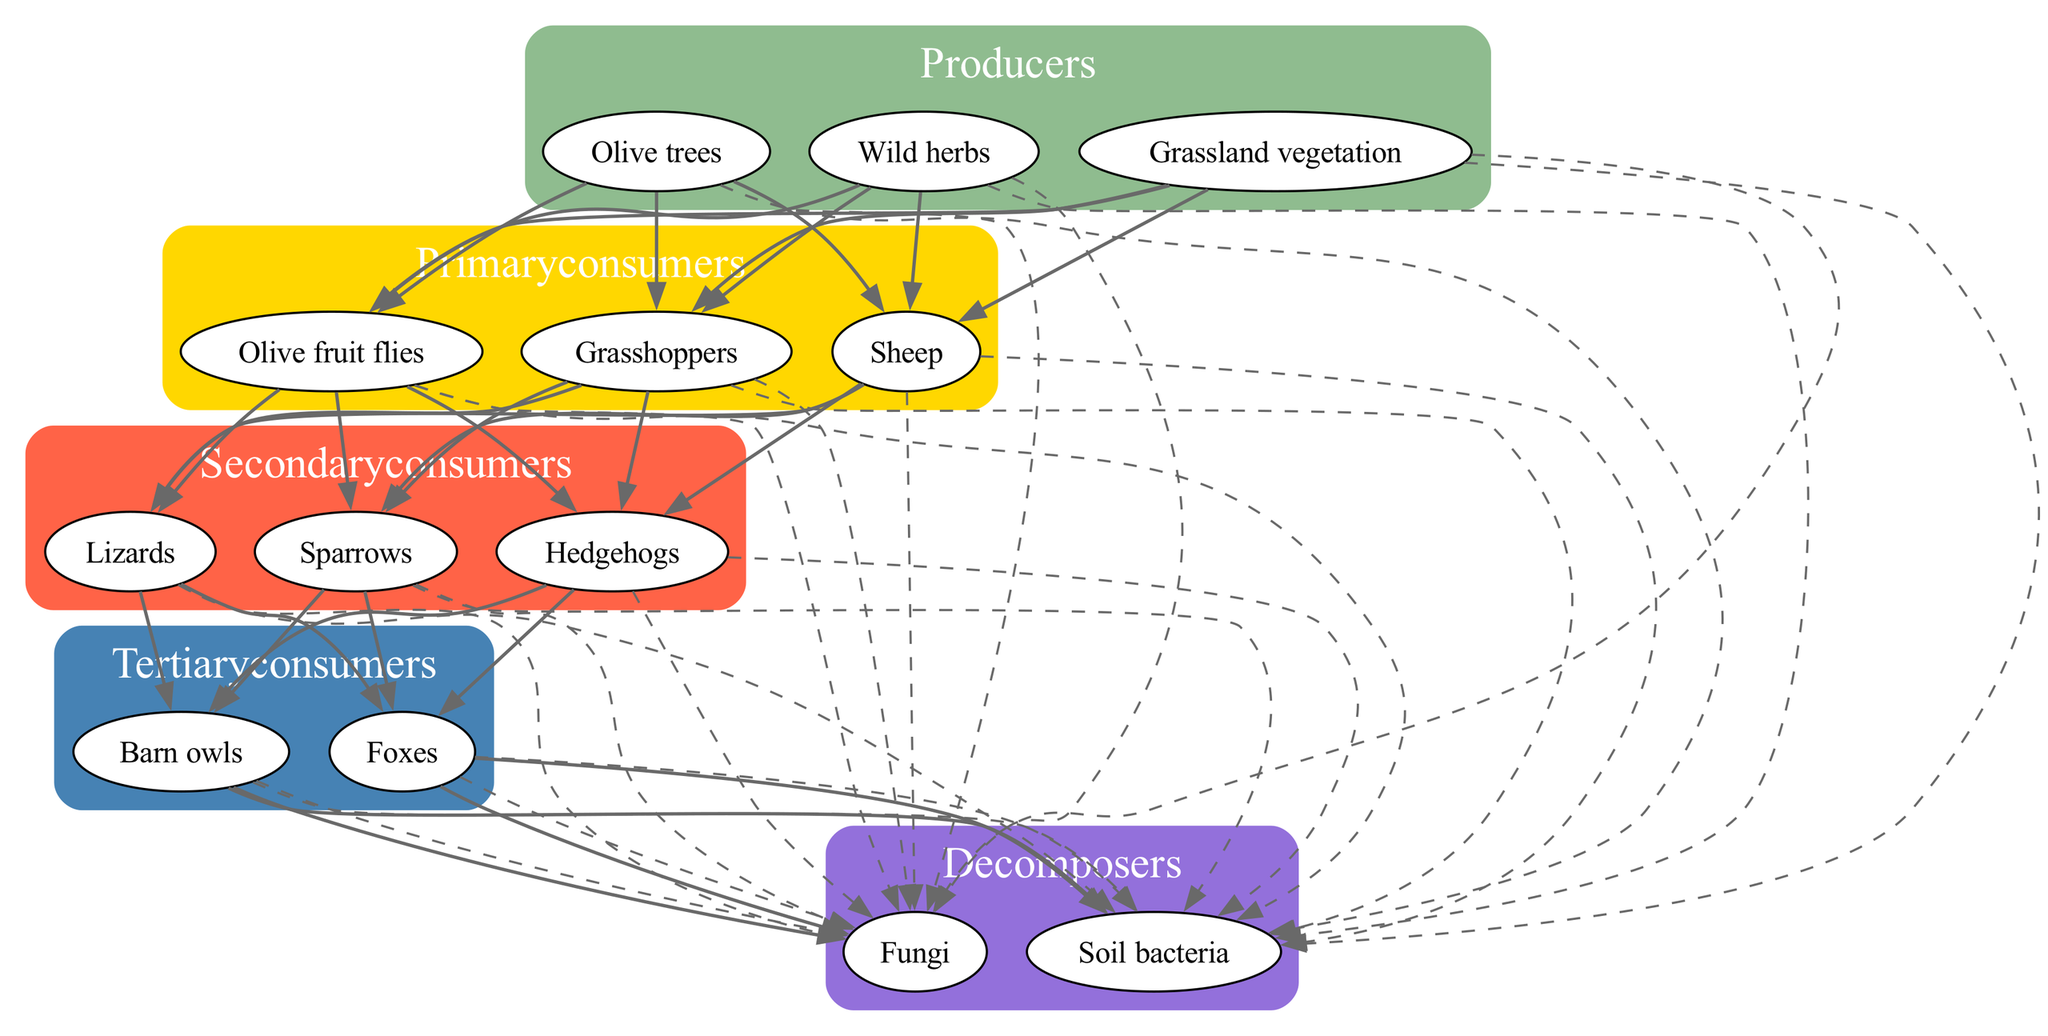What are the producers in this food chain? The diagram lists three organisms as producers: olive trees, wild herbs, and grassland vegetation. These are the starting point of the food chain.
Answer: Olive trees, wild herbs, grassland vegetation How many primary consumers are present? The diagram indicates there are three primary consumers: olive fruit flies, grasshoppers, and sheep. This is counted directly from the primary consumer section of the diagram.
Answer: 3 Which organisms directly feed on olive trees? Olive fruit flies are identified as primary consumers that feed directly on olive trees. They represent an interaction between producers and primary consumers.
Answer: Olive fruit flies What is the role of decomposers in the food chain? Decomposers like fungi and soil bacteria recycle nutrients back into the ecosystem by breaking down dead plants and animals. They are crucial for nutrient cycling in the food chain.
Answer: Nutrient recycling How many total organisms are in the secondary consumer category? According to the diagram, there are three organisms in the secondary consumer category: lizards, sparrows, and hedgehogs, giving us a total count.
Answer: 3 Which tertiary consumer preys on lizards? Barn owls are identified as tertiary consumers in this food chain, and they prey on lizards found in the secondary consumer category. This reflects the predatory relationship.
Answer: Barn owls What role do soil bacteria play in the ecosystem? Soil bacteria act as decomposers, breaking down organic matter, which helps to recycle nutrients back into the soil, supporting plant growth and ecosystem sustainability.
Answer: Decomposer How many edges lead from primary consumers to secondary consumers? There are three primary consumers and three secondary consumers. Each primary consumer can potentially interact with each secondary consumer, leading to nine edges in total connecting these levels.
Answer: 9 Which secondary consumer is at risk of predation by foxes? Foxes are identified as tertiary consumers that prey on secondary consumers. In this case, hedgehogs would specifically be at risk from foxes within the food chain.
Answer: Hedgehogs 